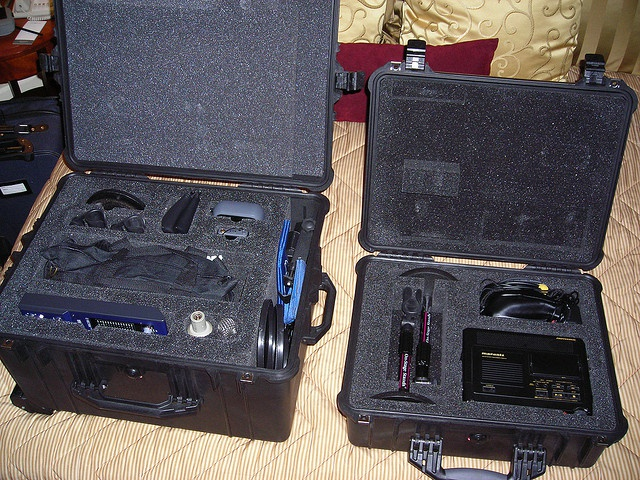Describe the objects in this image and their specific colors. I can see suitcase in black, gray, and navy tones, suitcase in black, gray, and purple tones, bed in black, ivory, and tan tones, suitcase in black, maroon, and gray tones, and handbag in black, maroon, darkgray, and gray tones in this image. 